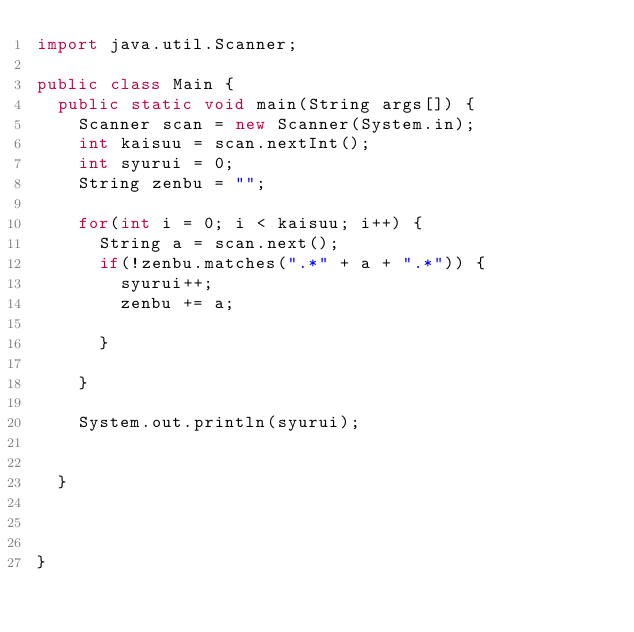<code> <loc_0><loc_0><loc_500><loc_500><_Java_>import java.util.Scanner;

public class Main {
	public static void main(String args[]) {
		Scanner scan = new Scanner(System.in);
		int kaisuu = scan.nextInt();
		int syurui = 0;
		String zenbu = "";
		
		for(int i = 0; i < kaisuu; i++) {
			String a = scan.next();
			if(!zenbu.matches(".*" + a + ".*")) {
				syurui++;
				zenbu += a;
				
			}
			
		}
		
		System.out.println(syurui);
		
		
	}
		
		
		
}</code> 